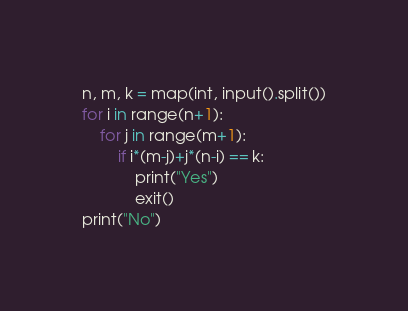Convert code to text. <code><loc_0><loc_0><loc_500><loc_500><_Python_>n, m, k = map(int, input().split())
for i in range(n+1):
    for j in range(m+1):
        if i*(m-j)+j*(n-i) == k:
            print("Yes")
            exit()
print("No")</code> 